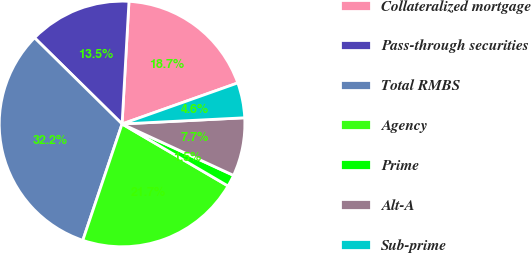Convert chart. <chart><loc_0><loc_0><loc_500><loc_500><pie_chart><fcel>Collateralized mortgage<fcel>Pass-through securities<fcel>Total RMBS<fcel>Agency<fcel>Prime<fcel>Alt-A<fcel>Sub-prime<nl><fcel>18.68%<fcel>13.52%<fcel>32.2%<fcel>21.75%<fcel>1.55%<fcel>7.68%<fcel>4.62%<nl></chart> 